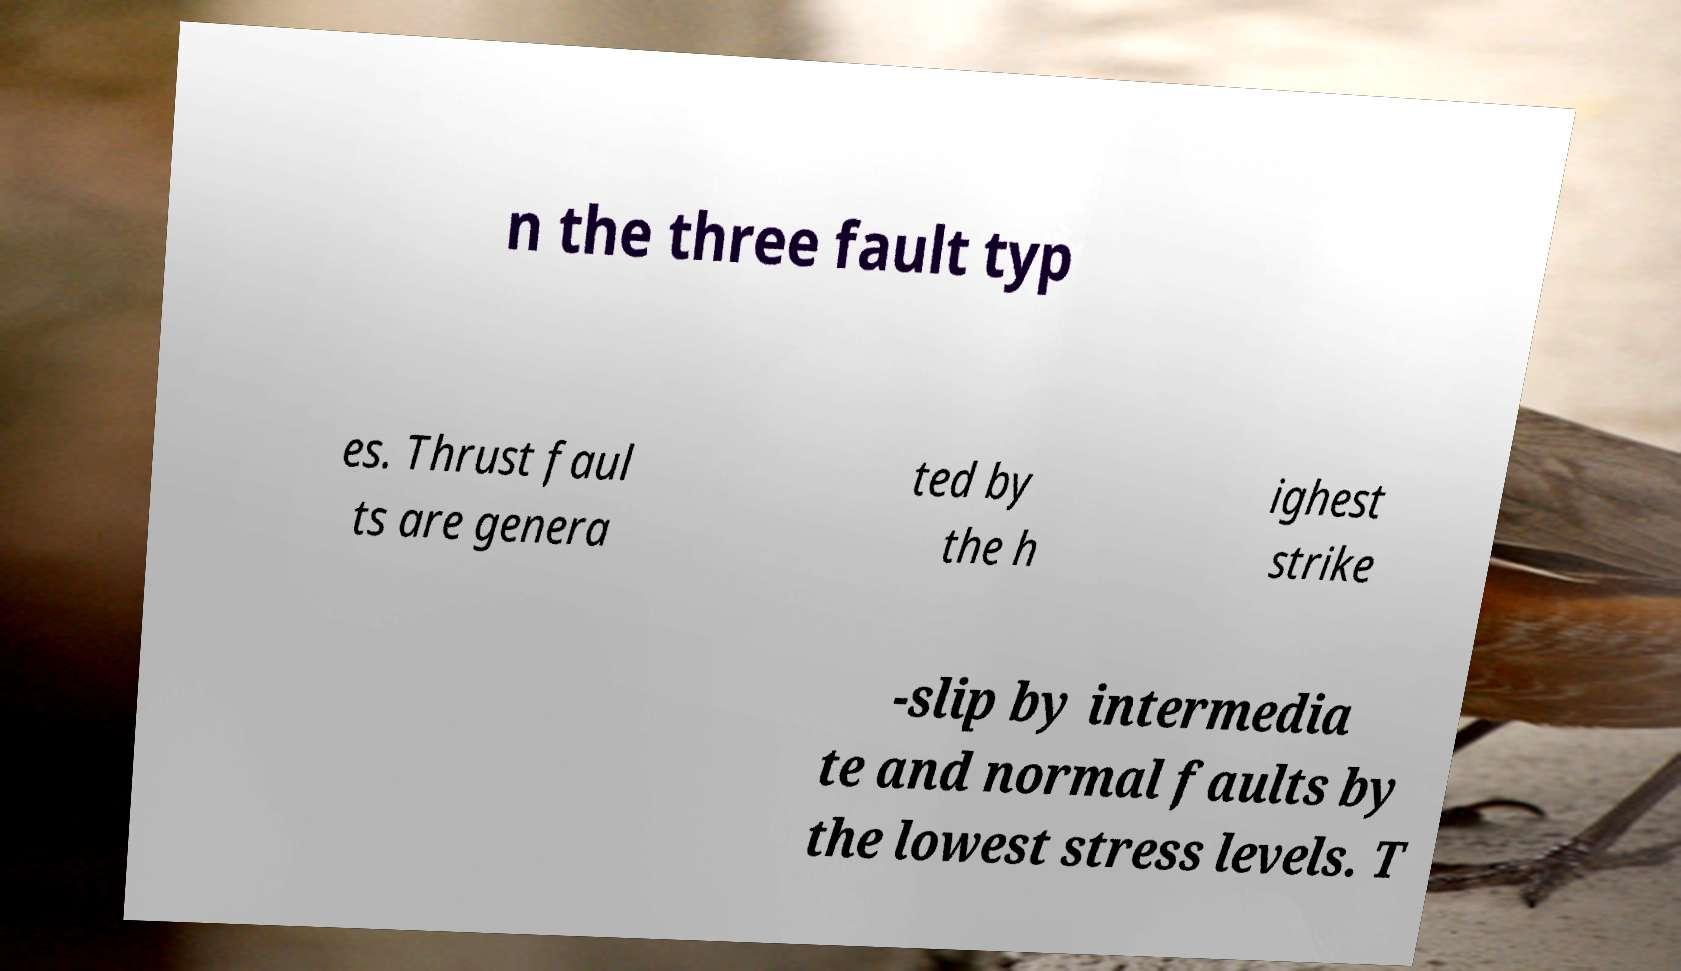I need the written content from this picture converted into text. Can you do that? n the three fault typ es. Thrust faul ts are genera ted by the h ighest strike -slip by intermedia te and normal faults by the lowest stress levels. T 